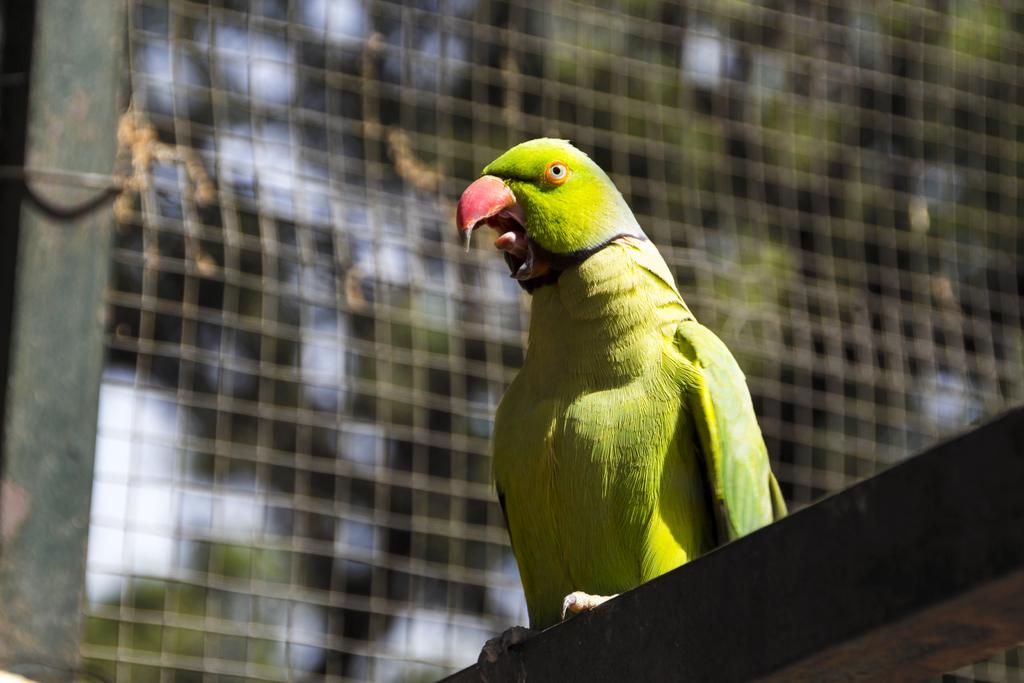What animal is located in the middle of the image? There is a parrot in the middle of the image. What can be seen in the background of the image? There is a fence and trees in the background of the image. What type of advertisement can be seen on the parrot's wing in the image? There is no advertisement present on the parrot's wing in the image. 